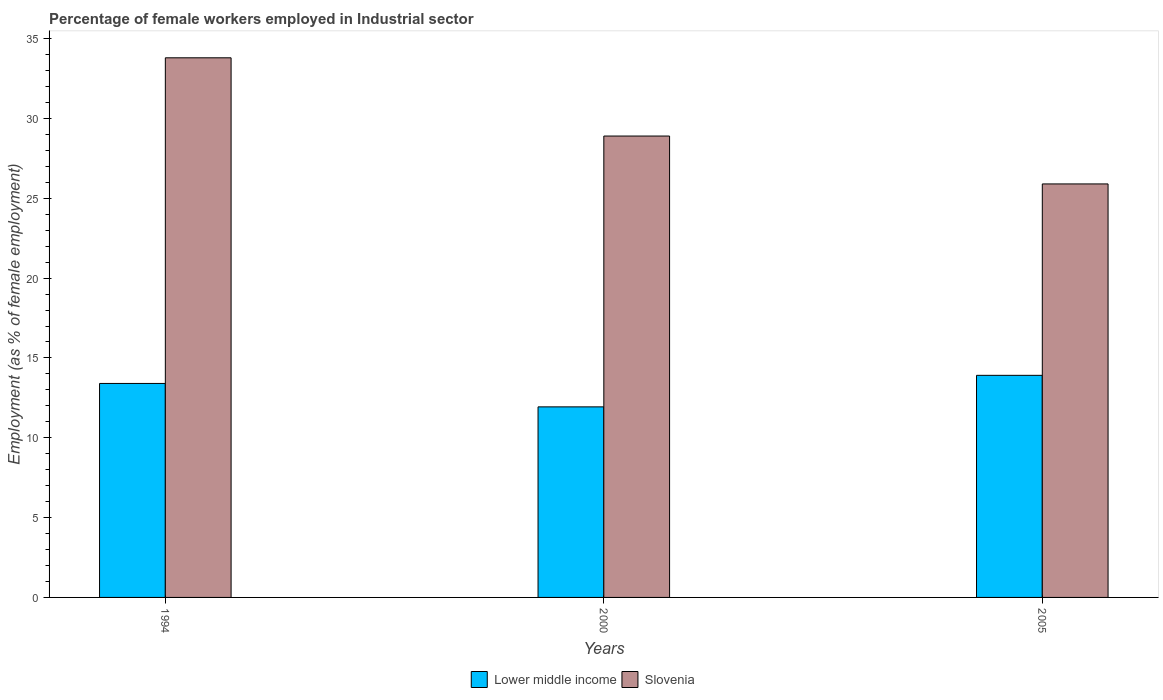How many different coloured bars are there?
Offer a terse response. 2. How many groups of bars are there?
Your answer should be compact. 3. Are the number of bars on each tick of the X-axis equal?
Give a very brief answer. Yes. What is the percentage of females employed in Industrial sector in Slovenia in 2005?
Make the answer very short. 25.9. Across all years, what is the maximum percentage of females employed in Industrial sector in Slovenia?
Your response must be concise. 33.8. Across all years, what is the minimum percentage of females employed in Industrial sector in Slovenia?
Your answer should be very brief. 25.9. What is the total percentage of females employed in Industrial sector in Slovenia in the graph?
Ensure brevity in your answer.  88.6. What is the difference between the percentage of females employed in Industrial sector in Slovenia in 1994 and that in 2005?
Offer a terse response. 7.9. What is the difference between the percentage of females employed in Industrial sector in Slovenia in 2000 and the percentage of females employed in Industrial sector in Lower middle income in 2005?
Your answer should be very brief. 14.99. What is the average percentage of females employed in Industrial sector in Lower middle income per year?
Your answer should be very brief. 13.08. In the year 1994, what is the difference between the percentage of females employed in Industrial sector in Lower middle income and percentage of females employed in Industrial sector in Slovenia?
Your answer should be very brief. -20.4. What is the ratio of the percentage of females employed in Industrial sector in Lower middle income in 1994 to that in 2000?
Provide a short and direct response. 1.12. What is the difference between the highest and the second highest percentage of females employed in Industrial sector in Slovenia?
Ensure brevity in your answer.  4.9. What is the difference between the highest and the lowest percentage of females employed in Industrial sector in Lower middle income?
Your response must be concise. 1.97. In how many years, is the percentage of females employed in Industrial sector in Slovenia greater than the average percentage of females employed in Industrial sector in Slovenia taken over all years?
Your response must be concise. 1. What does the 1st bar from the left in 1994 represents?
Keep it short and to the point. Lower middle income. What does the 2nd bar from the right in 1994 represents?
Offer a very short reply. Lower middle income. How many bars are there?
Your answer should be very brief. 6. Are all the bars in the graph horizontal?
Offer a very short reply. No. How many years are there in the graph?
Offer a very short reply. 3. Where does the legend appear in the graph?
Offer a terse response. Bottom center. How are the legend labels stacked?
Offer a very short reply. Horizontal. What is the title of the graph?
Provide a short and direct response. Percentage of female workers employed in Industrial sector. What is the label or title of the Y-axis?
Make the answer very short. Employment (as % of female employment). What is the Employment (as % of female employment) in Lower middle income in 1994?
Your answer should be compact. 13.4. What is the Employment (as % of female employment) of Slovenia in 1994?
Give a very brief answer. 33.8. What is the Employment (as % of female employment) of Lower middle income in 2000?
Provide a succinct answer. 11.94. What is the Employment (as % of female employment) of Slovenia in 2000?
Keep it short and to the point. 28.9. What is the Employment (as % of female employment) of Lower middle income in 2005?
Keep it short and to the point. 13.91. What is the Employment (as % of female employment) of Slovenia in 2005?
Provide a short and direct response. 25.9. Across all years, what is the maximum Employment (as % of female employment) in Lower middle income?
Provide a succinct answer. 13.91. Across all years, what is the maximum Employment (as % of female employment) of Slovenia?
Offer a terse response. 33.8. Across all years, what is the minimum Employment (as % of female employment) in Lower middle income?
Provide a short and direct response. 11.94. Across all years, what is the minimum Employment (as % of female employment) in Slovenia?
Provide a short and direct response. 25.9. What is the total Employment (as % of female employment) of Lower middle income in the graph?
Offer a terse response. 39.25. What is the total Employment (as % of female employment) of Slovenia in the graph?
Offer a very short reply. 88.6. What is the difference between the Employment (as % of female employment) in Lower middle income in 1994 and that in 2000?
Your answer should be very brief. 1.47. What is the difference between the Employment (as % of female employment) in Lower middle income in 1994 and that in 2005?
Make the answer very short. -0.51. What is the difference between the Employment (as % of female employment) of Slovenia in 1994 and that in 2005?
Keep it short and to the point. 7.9. What is the difference between the Employment (as % of female employment) of Lower middle income in 2000 and that in 2005?
Offer a terse response. -1.97. What is the difference between the Employment (as % of female employment) of Slovenia in 2000 and that in 2005?
Make the answer very short. 3. What is the difference between the Employment (as % of female employment) in Lower middle income in 1994 and the Employment (as % of female employment) in Slovenia in 2000?
Provide a short and direct response. -15.5. What is the difference between the Employment (as % of female employment) in Lower middle income in 1994 and the Employment (as % of female employment) in Slovenia in 2005?
Give a very brief answer. -12.5. What is the difference between the Employment (as % of female employment) of Lower middle income in 2000 and the Employment (as % of female employment) of Slovenia in 2005?
Offer a terse response. -13.96. What is the average Employment (as % of female employment) in Lower middle income per year?
Provide a short and direct response. 13.08. What is the average Employment (as % of female employment) of Slovenia per year?
Ensure brevity in your answer.  29.53. In the year 1994, what is the difference between the Employment (as % of female employment) in Lower middle income and Employment (as % of female employment) in Slovenia?
Offer a terse response. -20.4. In the year 2000, what is the difference between the Employment (as % of female employment) of Lower middle income and Employment (as % of female employment) of Slovenia?
Your response must be concise. -16.96. In the year 2005, what is the difference between the Employment (as % of female employment) in Lower middle income and Employment (as % of female employment) in Slovenia?
Offer a very short reply. -11.99. What is the ratio of the Employment (as % of female employment) of Lower middle income in 1994 to that in 2000?
Ensure brevity in your answer.  1.12. What is the ratio of the Employment (as % of female employment) in Slovenia in 1994 to that in 2000?
Offer a terse response. 1.17. What is the ratio of the Employment (as % of female employment) in Lower middle income in 1994 to that in 2005?
Give a very brief answer. 0.96. What is the ratio of the Employment (as % of female employment) of Slovenia in 1994 to that in 2005?
Make the answer very short. 1.3. What is the ratio of the Employment (as % of female employment) of Lower middle income in 2000 to that in 2005?
Offer a very short reply. 0.86. What is the ratio of the Employment (as % of female employment) of Slovenia in 2000 to that in 2005?
Your answer should be very brief. 1.12. What is the difference between the highest and the second highest Employment (as % of female employment) in Lower middle income?
Provide a short and direct response. 0.51. What is the difference between the highest and the lowest Employment (as % of female employment) in Lower middle income?
Offer a very short reply. 1.97. 